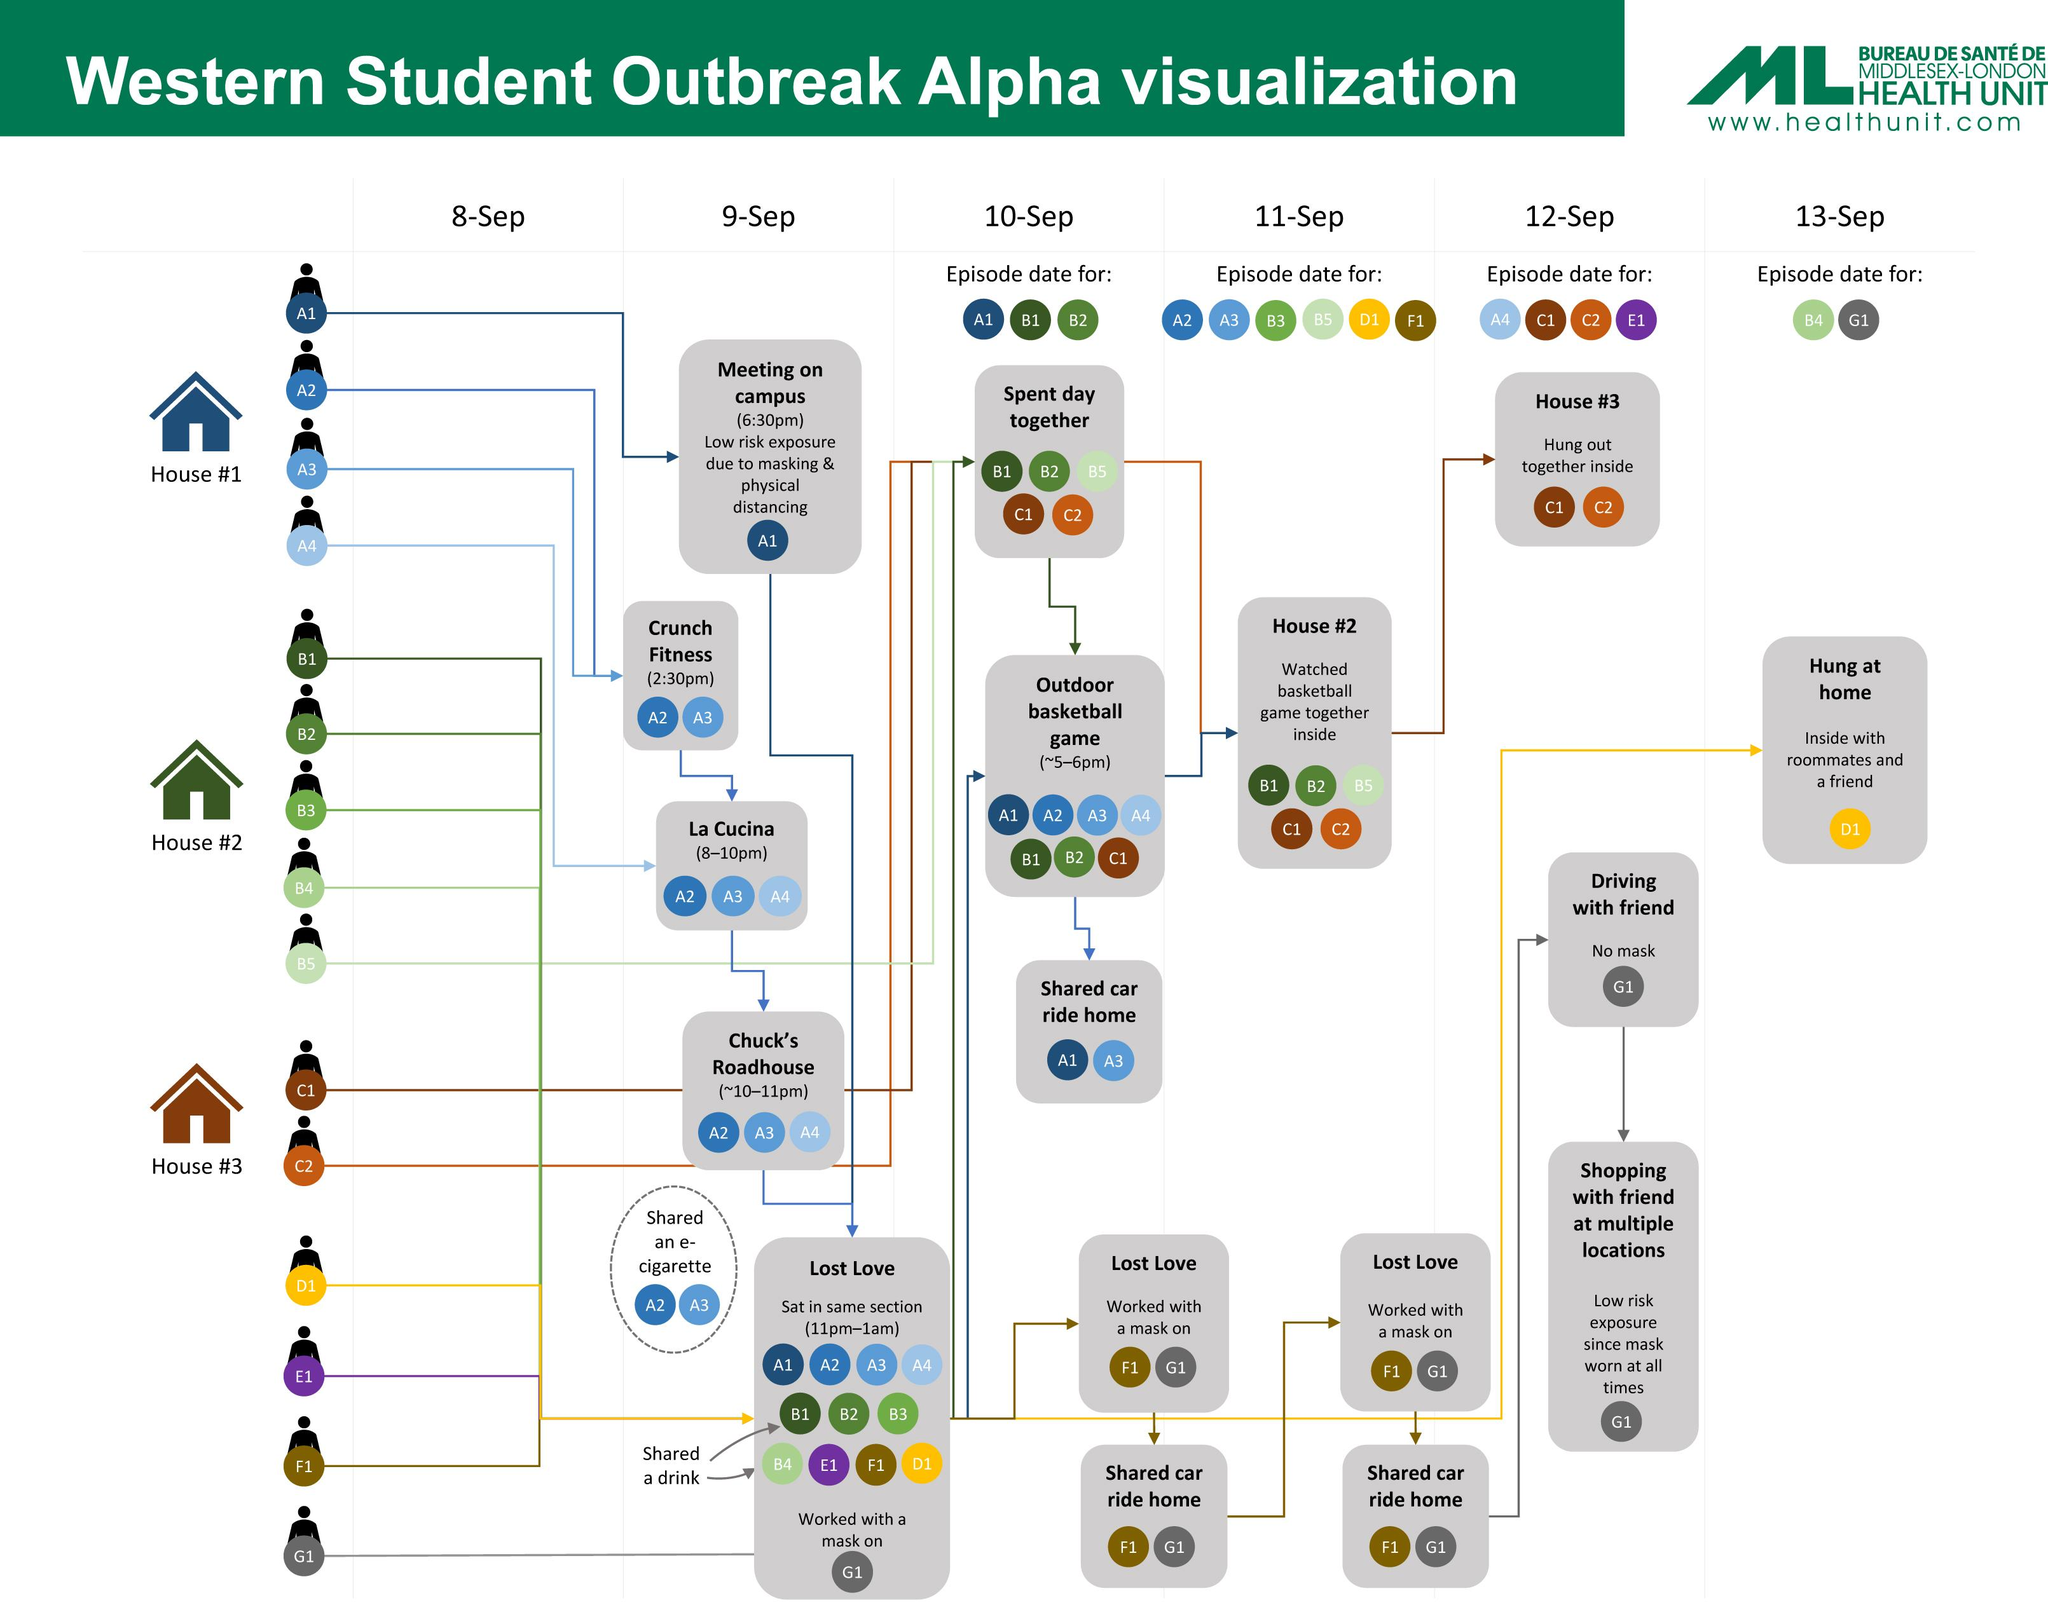Specify some key components in this picture. The color code given to person D1 is green, red, white, and yellow. All of those present at Chuck's Roadhouse were A2, A3, and A4. B1 shared a drink with B4 before B2. The individuals who were present at La Cucina are A2, A3, and A4. On the episode date for A1, B1, and B2, which was 10 September, the relevant information related to the episode was recorded. 